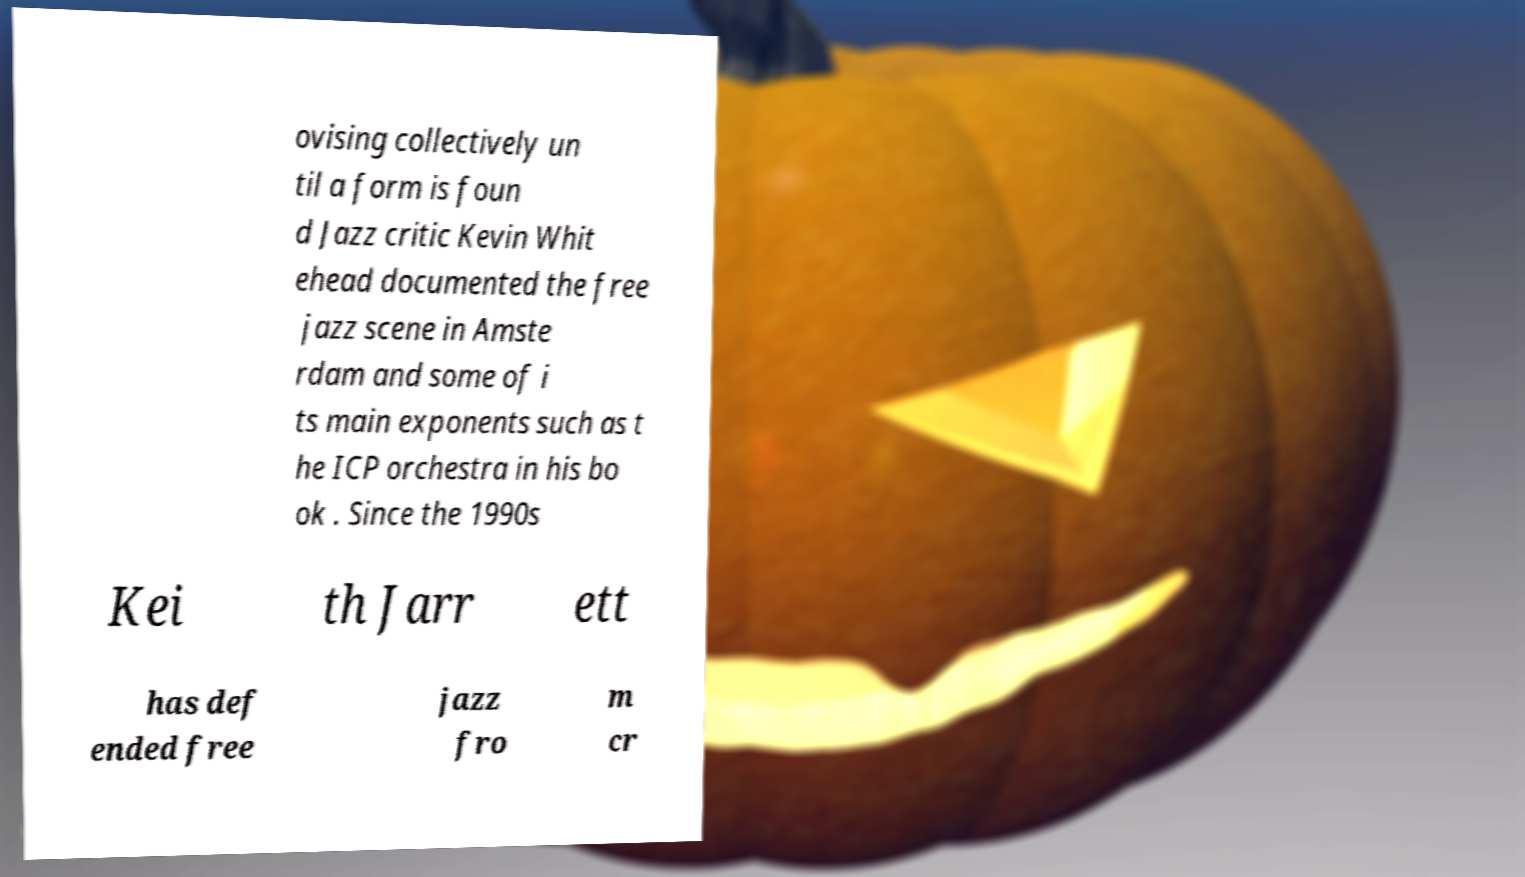Please read and relay the text visible in this image. What does it say? ovising collectively un til a form is foun d Jazz critic Kevin Whit ehead documented the free jazz scene in Amste rdam and some of i ts main exponents such as t he ICP orchestra in his bo ok . Since the 1990s Kei th Jarr ett has def ended free jazz fro m cr 